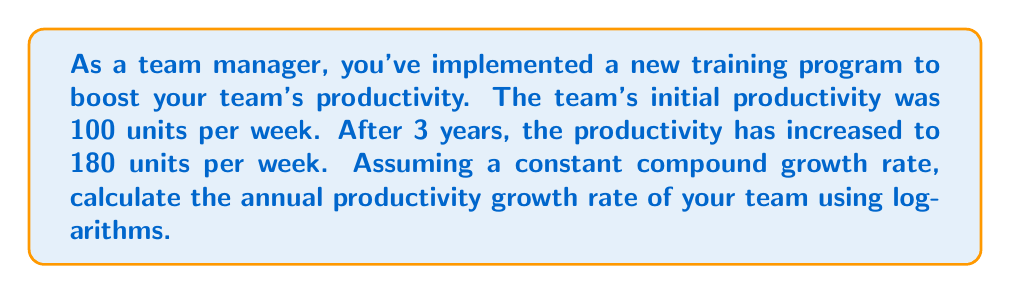What is the answer to this math problem? To solve this problem, we'll use the compound growth formula and logarithms:

1) The compound growth formula is:
   $$A = P(1 + r)^t$$
   Where:
   $A$ = Final value
   $P$ = Initial value
   $r$ = Annual growth rate (as a decimal)
   $t$ = Time in years

2) Substituting our known values:
   $$180 = 100(1 + r)^3$$

3) Divide both sides by 100:
   $$1.8 = (1 + r)^3$$

4) Take the natural logarithm of both sides:
   $$\ln(1.8) = \ln((1 + r)^3)$$

5) Use the logarithm property $\ln(x^n) = n\ln(x)$:
   $$\ln(1.8) = 3\ln(1 + r)$$

6) Divide both sides by 3:
   $$\frac{\ln(1.8)}{3} = \ln(1 + r)$$

7) Take $e$ to the power of both sides:
   $$e^{\frac{\ln(1.8)}{3}} = e^{\ln(1 + r)}$$

8) Simplify the right side:
   $$e^{\frac{\ln(1.8)}{3}} = 1 + r$$

9) Subtract 1 from both sides:
   $$e^{\frac{\ln(1.8)}{3}} - 1 = r$$

10) Calculate the value:
    $$r \approx 0.2185$$

11) Convert to a percentage:
    $$r \approx 21.85\%$$
Answer: The annual productivity growth rate of the team is approximately 21.85%. 